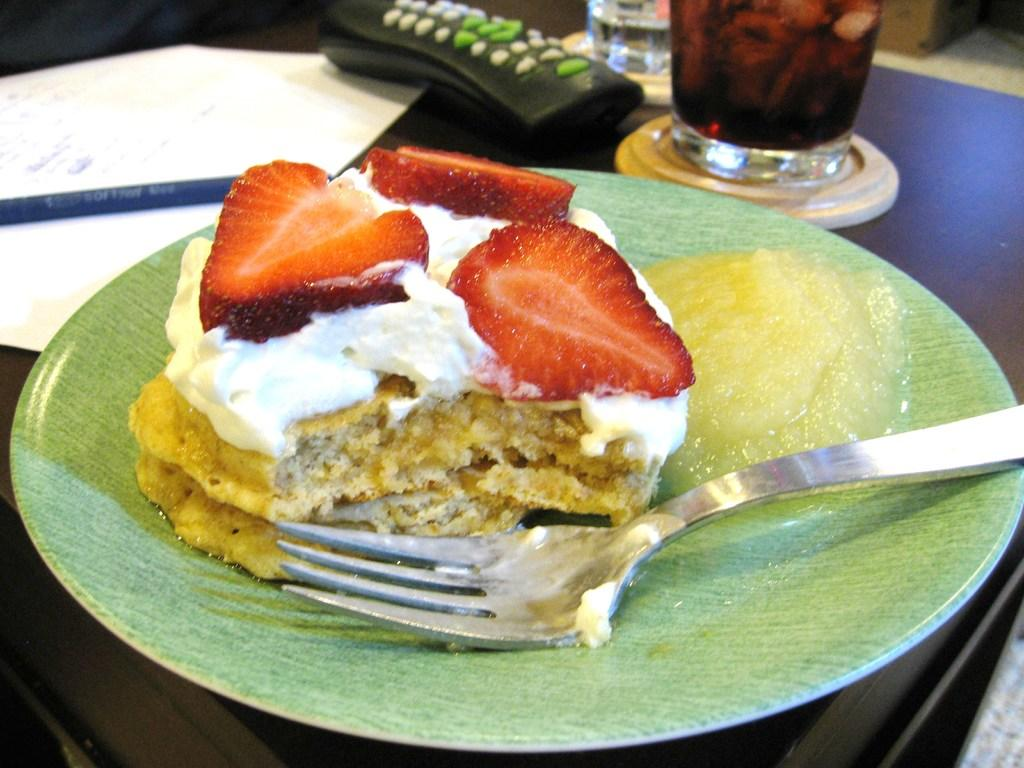What is placed on the plate in the image? There is a food item placed on a plate in the image. What utensil is present in the image? There is a fork in the image. What is located in front of the plate? There is a paper, a pen, and a remote in front of the plate. How many glasses of drinks are on the table? There are two glasses of drinks on the table. What type of jewel is being weighed on the scale in the image? There is no scale or jewel present in the image. 